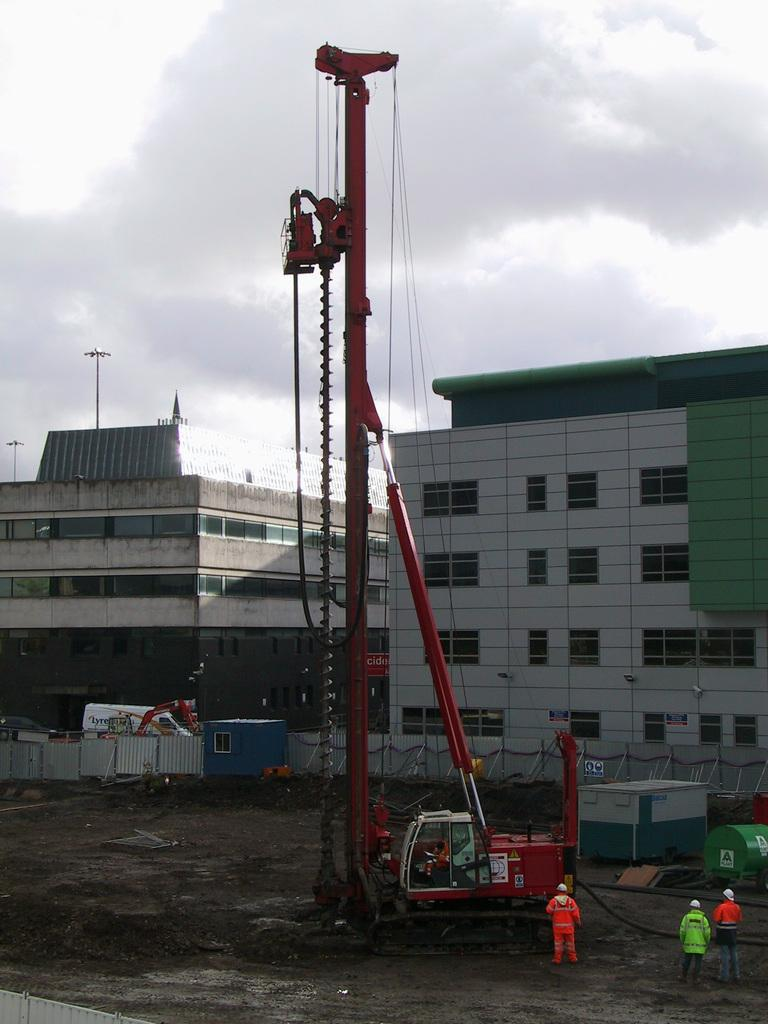What can be seen in the image? There are vehicles and three persons in the image. What is visible in the background of the image? There are buildings, poles, and the sky visible in the background of the image. What is the condition of the sky in the image? The sky is visible in the background of the image, and clouds are present. How many kittens can be seen playing downtown in the image? There are no kittens or downtown location present in the image. 